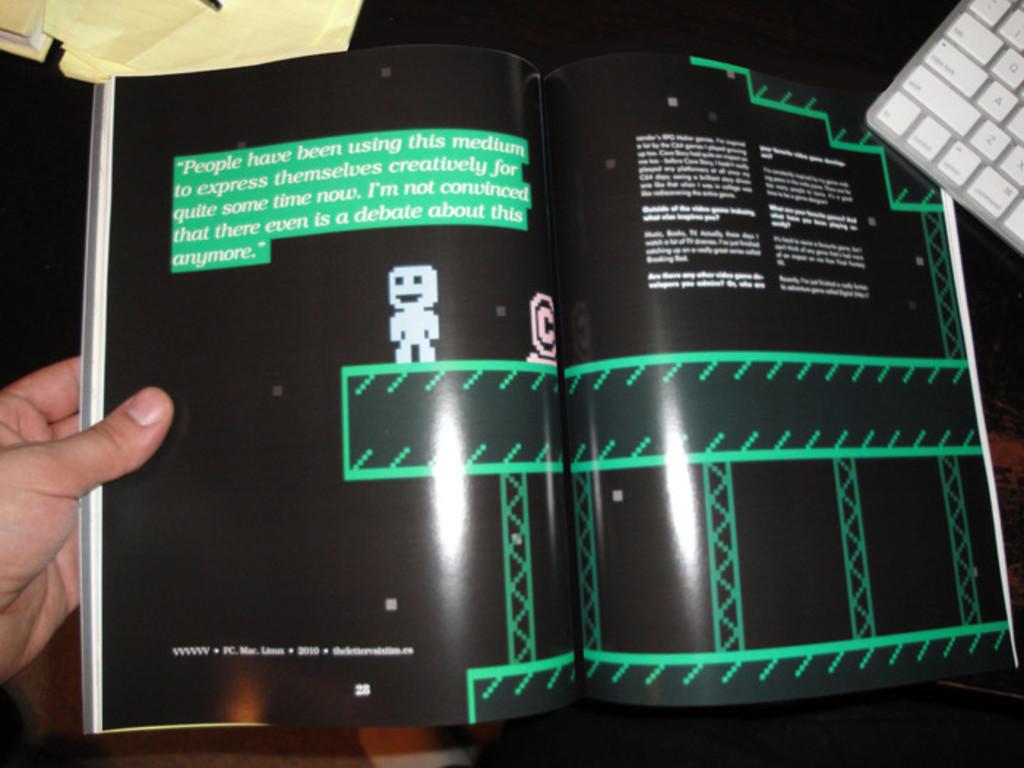What's the first word in quotes?
Make the answer very short. People. Does the article say that people aren't using the medium extensively?
Make the answer very short. No. 